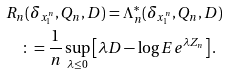<formula> <loc_0><loc_0><loc_500><loc_500>& R _ { n } ( \delta _ { x _ { 1 } ^ { n } } , Q _ { n } , D ) = \Lambda ^ { * } _ { n } ( \delta _ { x _ { 1 } ^ { n } } , Q _ { n } , D ) \\ & \quad \colon = \frac { 1 } { n } \sup _ { \lambda \leq 0 } \left [ \lambda D - \log E e ^ { \lambda Z _ { n } } \right ] .</formula> 